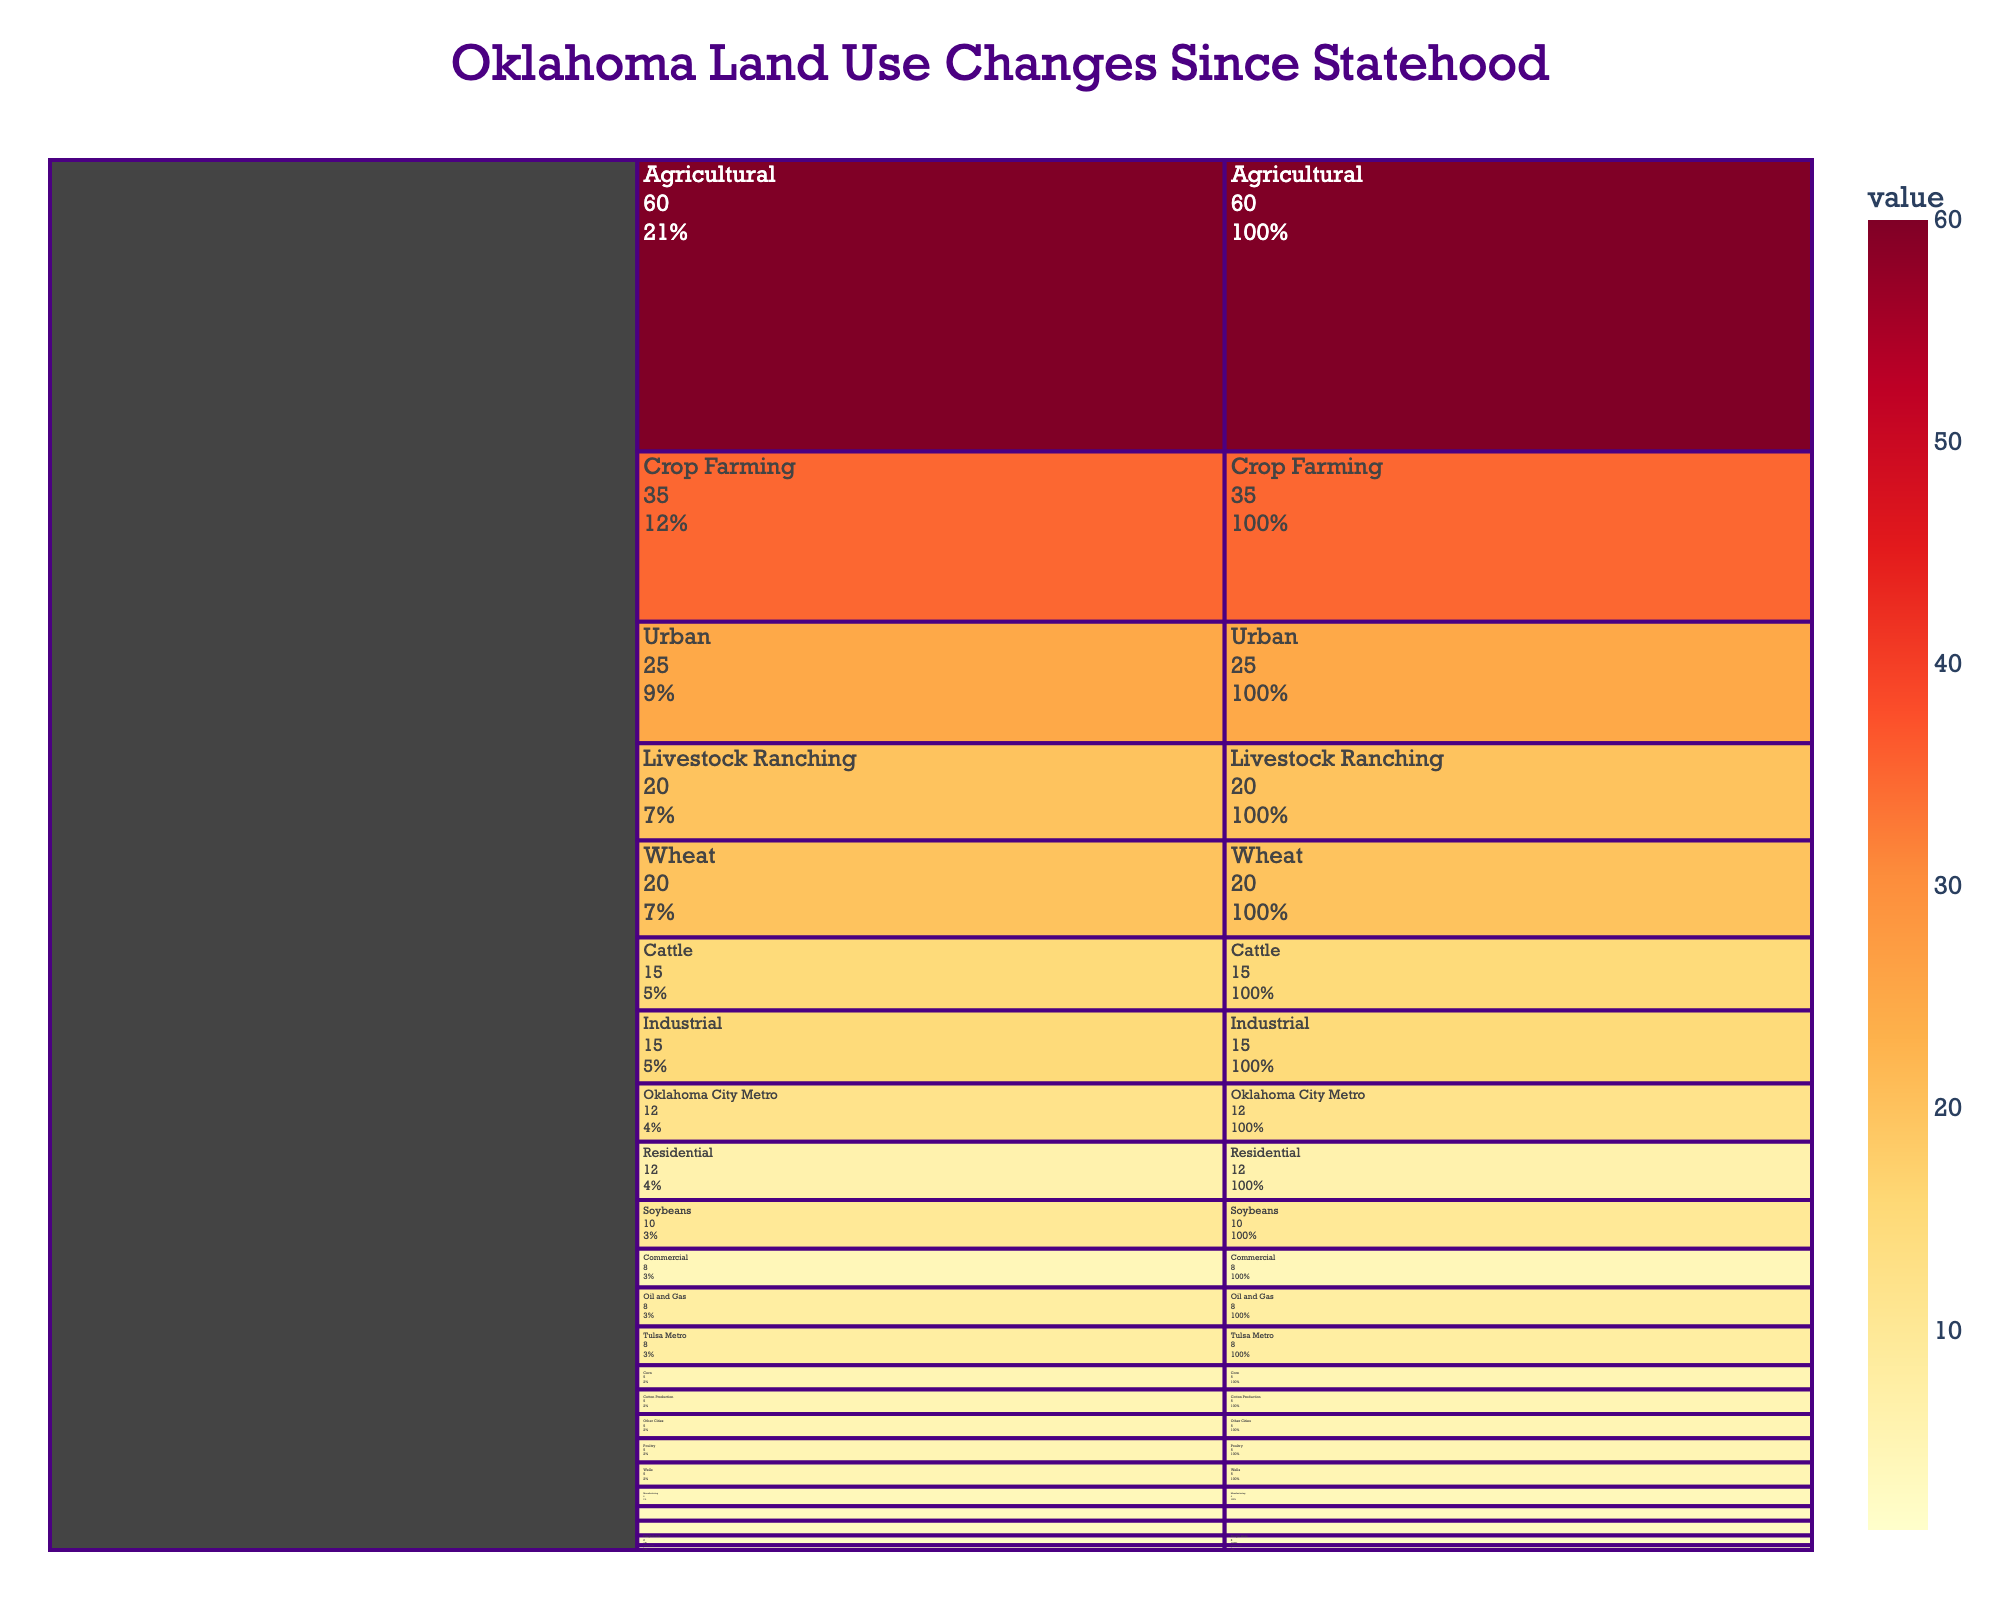what’s the largest category of land use in Oklahoma since statehood? From the Icicle chart, the largest block at the root level is "Agricultural", indicating it has the highest value compared to other root-level categories.
Answer: Agricultural Which subcategory under Urban has the smallest percentage? Within the Urban segment, the blocks show "Oklahoma City Metro", "Tulsa Metro", and "Other Cities". The smallest one is "Other Cities" at 5.
Answer: Other Cities What percentage of Crop Farming is dedicated to Soybeans? In the Crop Farming subcategory, Soybeans account for 10 out of the total 35 (20+10+5). This can be calculated as (10/35) * 100 ≈ 28.6%.
Answer: 28.6% Which subcategory under Industrial has the smallest value? The Industrial category contains "Oil and Gas", "Manufacturing", and "Railways". The smallest is "Railways" at 3.
Answer: Railways Combined, how much land use is devoted to Wheat and Cattle? Wheat under Crop Farming is 20, and Cattle under Livestock Ranching is 15. Summing these, 20 + 15 = 35.
Answer: 35 Which area has a higher percentage of Residential land use, Oklahoma City Metro, or Tulsa Metro? Oklahoma City Metro Residential is 7 out of 12. Tulsa Metro Residential is 5 out of 8. Calculating percentages: (7/12)*100 ≈ 58.3% for Oklahoma City and (5/8)*100 = 62.5% for Tulsa.
Answer: Tulsa Metro What is the difference in land use value between Oil and Gas and Manufacturing? Oil and Gas has a value of 8, while Manufacturing is 4. The difference is 8 - 4 = 4.
Answer: 4 How many distinct subcategories does Crop Farming have? Looking at the Crop Farming block, we see three subcategories: Wheat, Soybeans, and Corn.
Answer: 3 Which has a larger land use value: Cotton Production or Poultry? Cotton Production under Agricultural has a value of 5, while Poultry under Livestock Ranching is also 5, so they are equal.
Answer: Equal What subcategory within Industrial has the highest value and how much is it? In the Industrial segment, the highest value subcategory is "Oil and Gas" at 8.
Answer: Oil and Gas, 8 